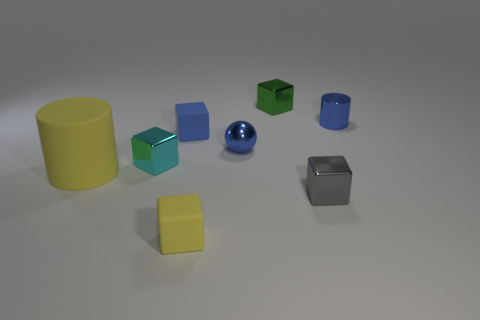Subtract all blue blocks. How many blocks are left? 4 Subtract all small cyan metal blocks. How many blocks are left? 4 Subtract all purple blocks. Subtract all purple spheres. How many blocks are left? 5 Add 1 tiny matte things. How many objects exist? 9 Subtract all cylinders. How many objects are left? 6 Add 6 tiny blue metal balls. How many tiny blue metal balls are left? 7 Add 5 tiny cyan objects. How many tiny cyan objects exist? 6 Subtract 1 blue spheres. How many objects are left? 7 Subtract all cyan rubber balls. Subtract all big yellow things. How many objects are left? 7 